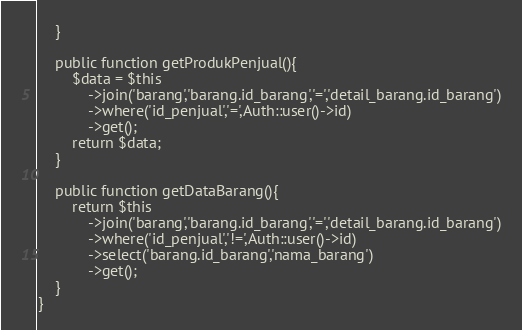<code> <loc_0><loc_0><loc_500><loc_500><_PHP_>    }

    public function getProdukPenjual(){
        $data = $this
            ->join('barang','barang.id_barang','=','detail_barang.id_barang')
            ->where('id_penjual','=',Auth::user()->id)
            ->get();
        return $data;
    }

    public function getDataBarang(){
        return $this
            ->join('barang','barang.id_barang','=','detail_barang.id_barang')
            ->where('id_penjual','!=',Auth::user()->id)
            ->select('barang.id_barang','nama_barang')
            ->get();
    }
}
</code> 